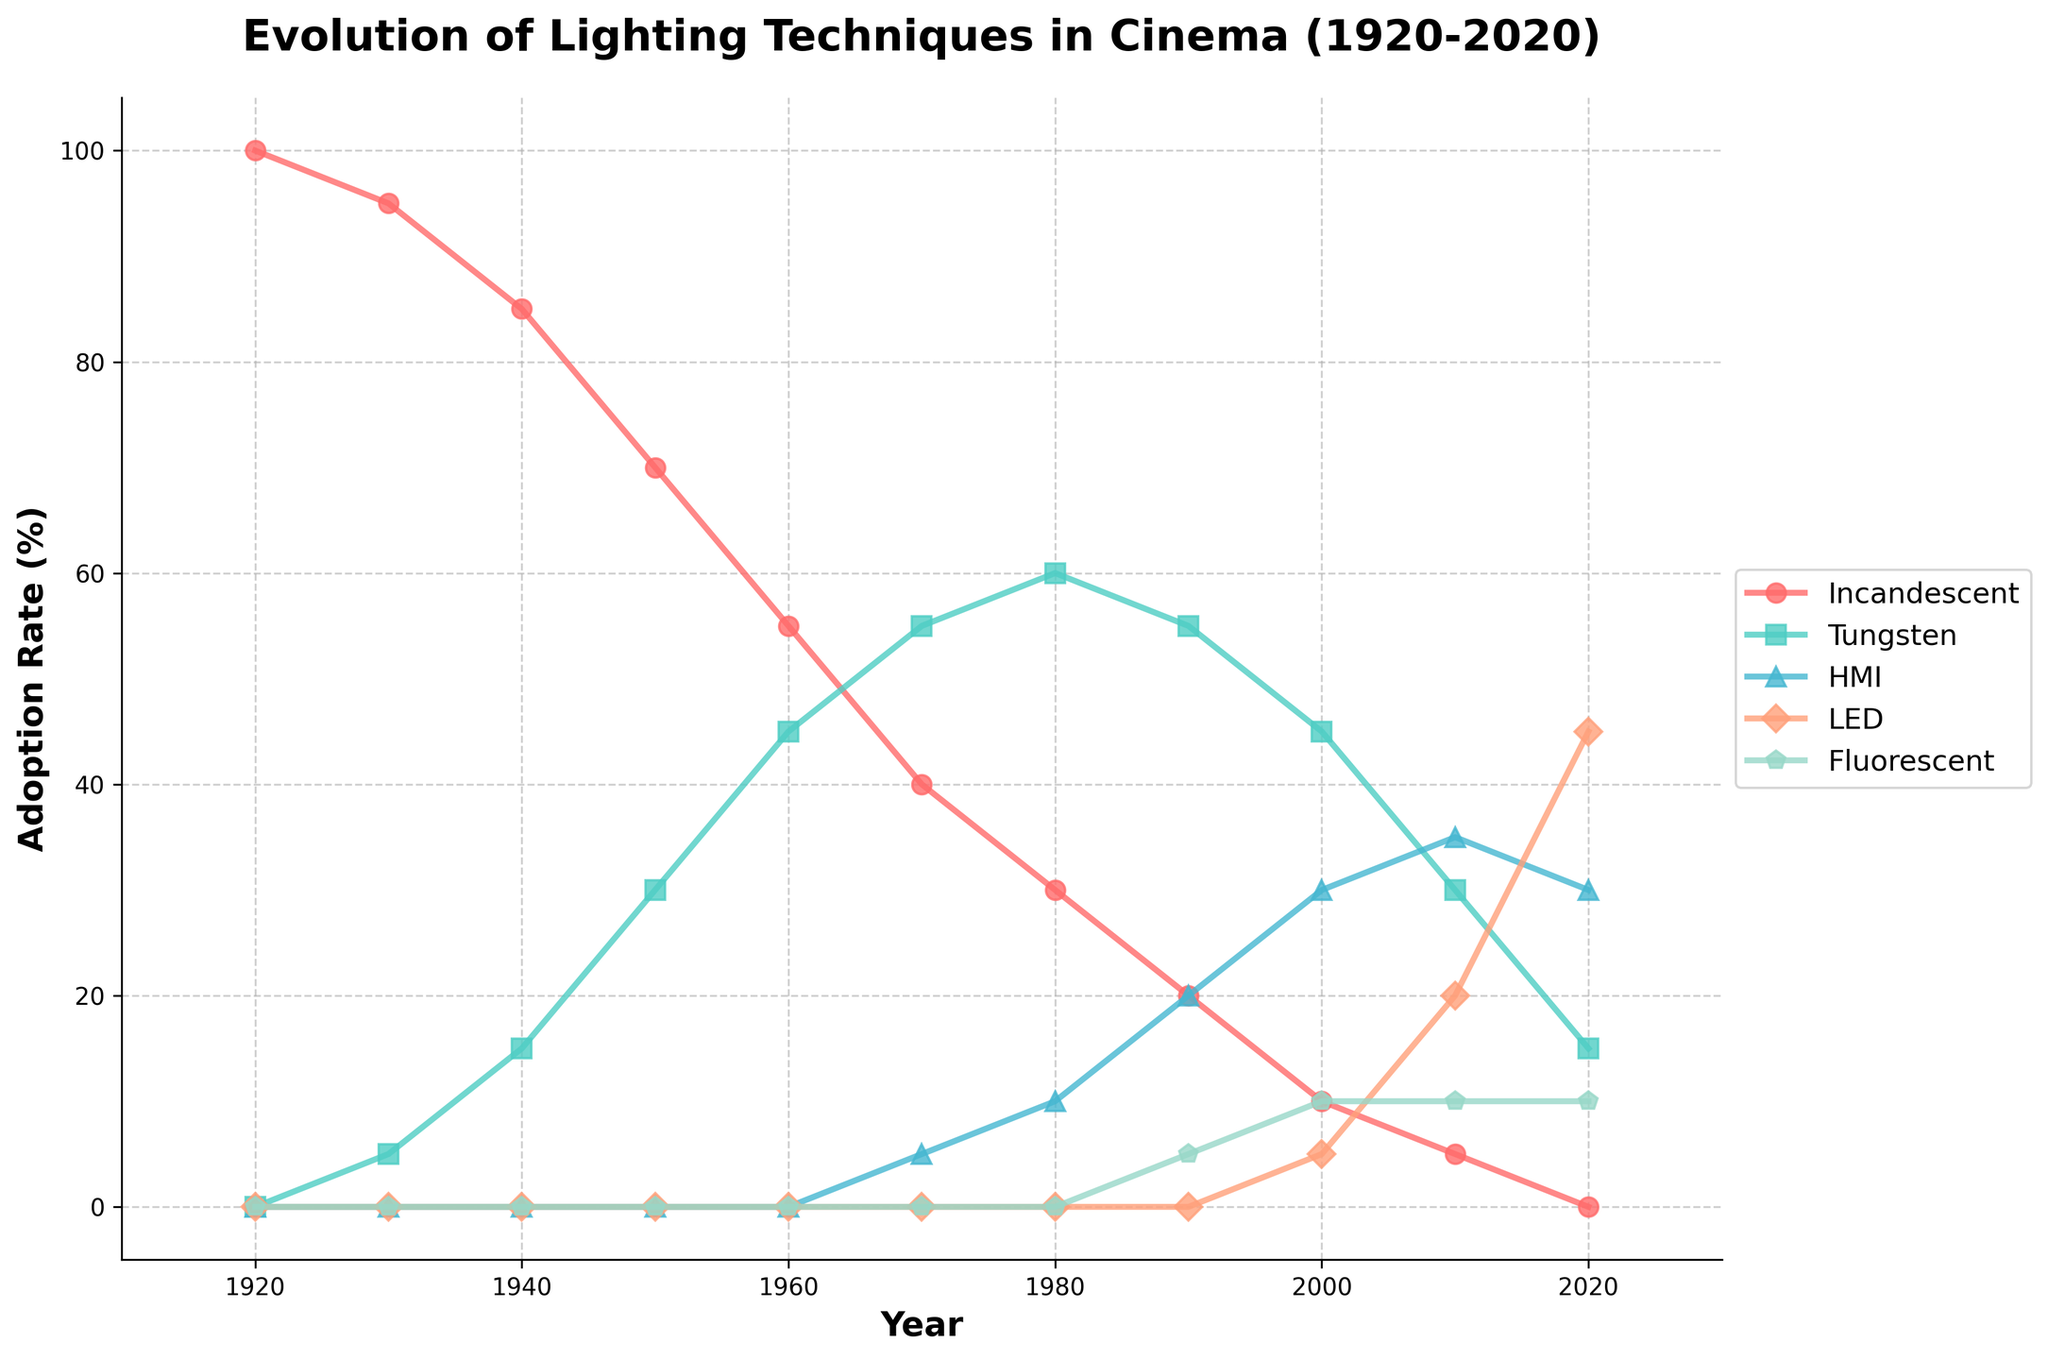What lighting technology had the highest adoption rate in 1920? Incandescent had the highest adoption rate in 1920 as it's the only technology at 100%.
Answer: Incandescent In 2020, which lighting technology has the lowest adoption rate? By 2020, Tungsten had the lowest adoption rate at 15%, as seen from the plot.
Answer: Tungsten Compare the adoption rates of HMI and LED in the year 2010. In 2010, HMI's adoption rate is 35%, and LED's adoption rate is 20%, so HMI is higher.
Answer: HMI is higher By how much did the adoption rate of Tungsten lighting change from 1950 to 1980? In 1950, Tungsten adoption rate was 30%. By 1980, it increased to 60%. The change is 60% - 30% = 30%.
Answer: 30% What is the average adoption rate of Fluorescent lighting from 1990 to 2020? The adoption rates for Fluorescent lighting in 1990, 2000, 2010, and 2020 are 5%, 10%, 10%, and 10% respectively. Average = (5+10+10+10)/4 = 8.75%.
Answer: 8.75% Which lighting technology showed an increasing trend continuously from 1920 to 2020? LED shows a continuous increasing trend from 0% in 2000 to 45% in 2020.
Answer: LED What is the difference between the highest adoption rate of LED and HMI across the timeline? The highest adoption rate of LED is 45% in 2020. The highest adoption rate of HMI is 35% in 2010. The difference is 45% - 35% = 10%.
Answer: 10% Between which consecutive decades did the adoption rate of Incandescent drop the most? The largest drop for Incandescent is from 1950 (70%) to 1960 (55%), a drop of 15%.
Answer: 1950 to 1960 What proportional change occurred in the adoption rate of Tungsten lighting from 1930 to 2020? In 1930, Tungsten adoption rate was 5%, and in 2020 it was 15%. Proportional change = (15-5)/5 = 2, or 200% increase.
Answer: 200% Which lighting technology had consistent adoption rates from 1990 to 2020? Fluorescent consistently had an adoption rate of 10% from 2000 to 2020.
Answer: Fluorescent 